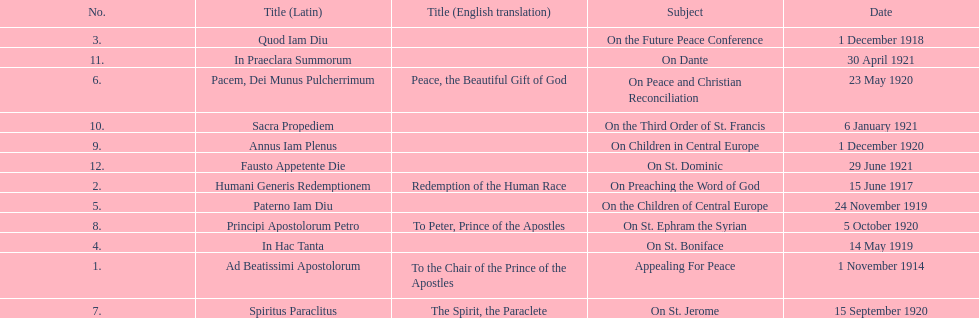How many titles are listed in the table? 12. 